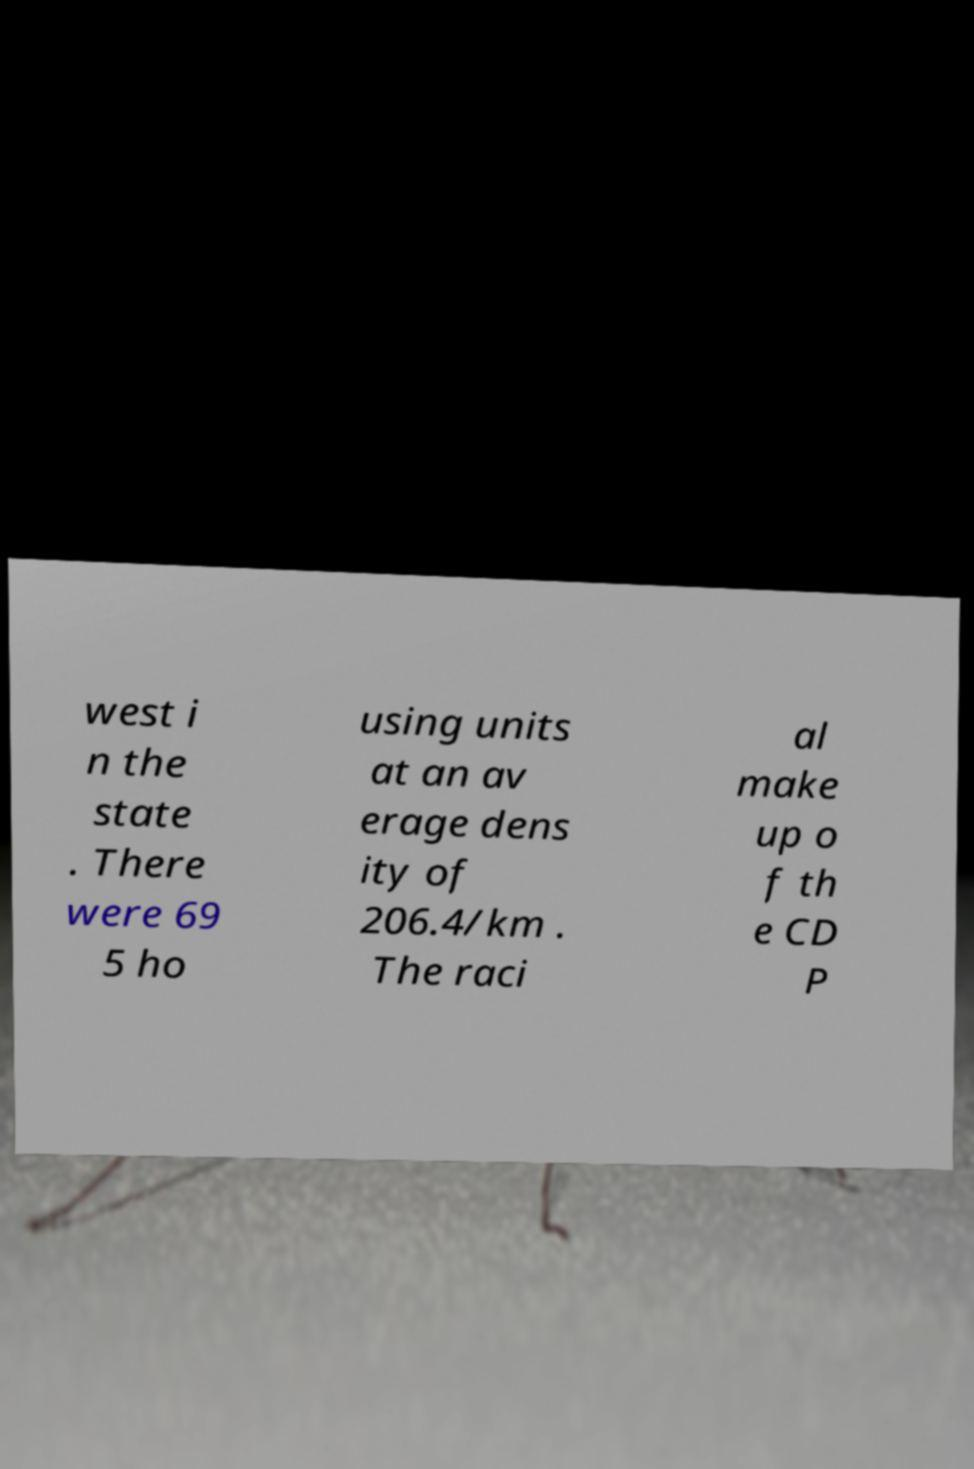Please identify and transcribe the text found in this image. west i n the state . There were 69 5 ho using units at an av erage dens ity of 206.4/km . The raci al make up o f th e CD P 